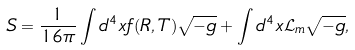<formula> <loc_0><loc_0><loc_500><loc_500>S = \frac { 1 } { 1 6 \pi } \int d ^ { 4 } x f ( R , T ) \sqrt { - g } + \int d ^ { 4 } x \mathcal { L } _ { m } \sqrt { - g } ,</formula> 